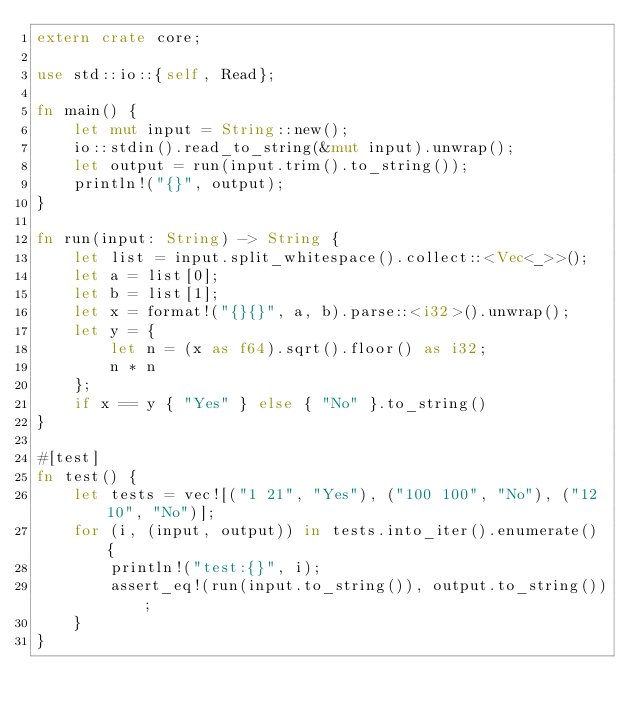<code> <loc_0><loc_0><loc_500><loc_500><_Rust_>extern crate core;

use std::io::{self, Read};

fn main() {
    let mut input = String::new();
    io::stdin().read_to_string(&mut input).unwrap();
    let output = run(input.trim().to_string());
    println!("{}", output);
}

fn run(input: String) -> String {
    let list = input.split_whitespace().collect::<Vec<_>>();
    let a = list[0];
    let b = list[1];
    let x = format!("{}{}", a, b).parse::<i32>().unwrap();
    let y = {
        let n = (x as f64).sqrt().floor() as i32;
        n * n
    };
    if x == y { "Yes" } else { "No" }.to_string()
}

#[test]
fn test() {
    let tests = vec![("1 21", "Yes"), ("100 100", "No"), ("12 10", "No")];
    for (i, (input, output)) in tests.into_iter().enumerate() {
        println!("test:{}", i);
        assert_eq!(run(input.to_string()), output.to_string());
    }
}
</code> 